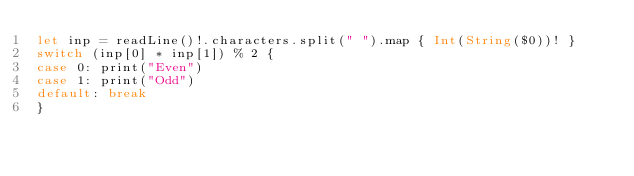<code> <loc_0><loc_0><loc_500><loc_500><_Swift_>let inp = readLine()!.characters.split(" ").map { Int(String($0))! }
switch (inp[0] * inp[1]) % 2 {
case 0: print("Even")
case 1: print("Odd")
default: break
}
</code> 